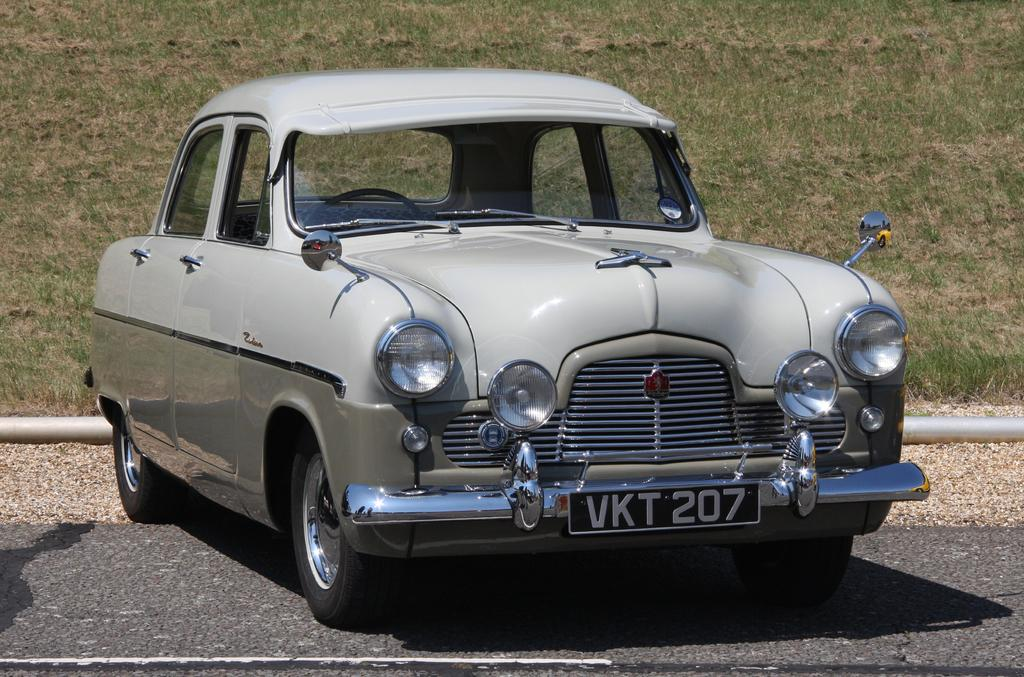What is the main subject of the image? There is a car on the road in the image. What else can be seen in the image besides the car? There is a pipe in the image. What type of natural environment is visible in the background of the image? There is grass visible in the background of the image. What type of wood can be seen supporting the car in the image? There is no wood present in the image, and the car is not being supported by any visible structure. 